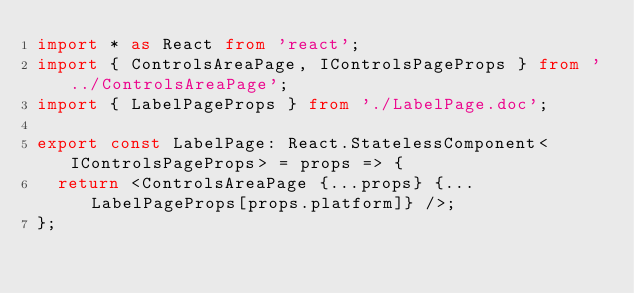Convert code to text. <code><loc_0><loc_0><loc_500><loc_500><_TypeScript_>import * as React from 'react';
import { ControlsAreaPage, IControlsPageProps } from '../ControlsAreaPage';
import { LabelPageProps } from './LabelPage.doc';

export const LabelPage: React.StatelessComponent<IControlsPageProps> = props => {
  return <ControlsAreaPage {...props} {...LabelPageProps[props.platform]} />;
};
</code> 